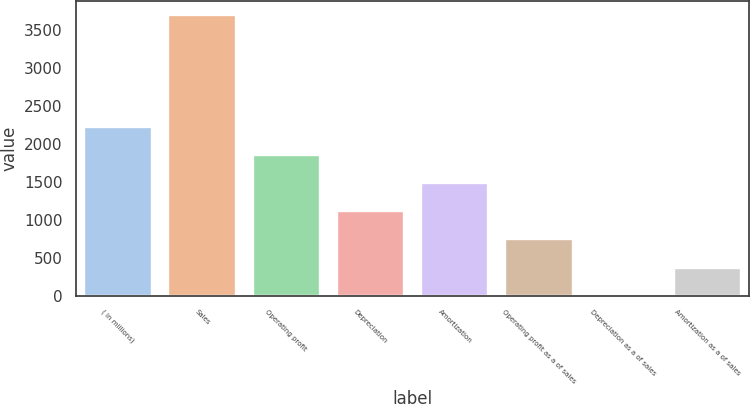Convert chart. <chart><loc_0><loc_0><loc_500><loc_500><bar_chart><fcel>( in millions)<fcel>Sales<fcel>Operating profit<fcel>Depreciation<fcel>Amortization<fcel>Operating profit as a of sales<fcel>Depreciation as a of sales<fcel>Amortization as a of sales<nl><fcel>2216.08<fcel>3692.8<fcel>1846.9<fcel>1108.54<fcel>1477.72<fcel>739.36<fcel>1<fcel>370.18<nl></chart> 